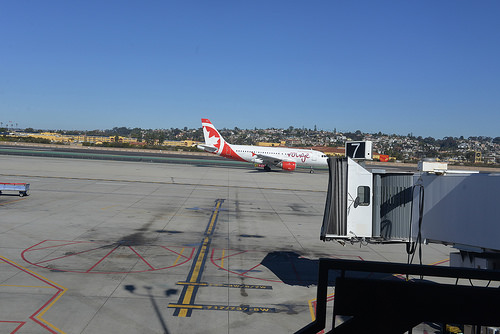<image>
Can you confirm if the airplane is above the ground? No. The airplane is not positioned above the ground. The vertical arrangement shows a different relationship. 